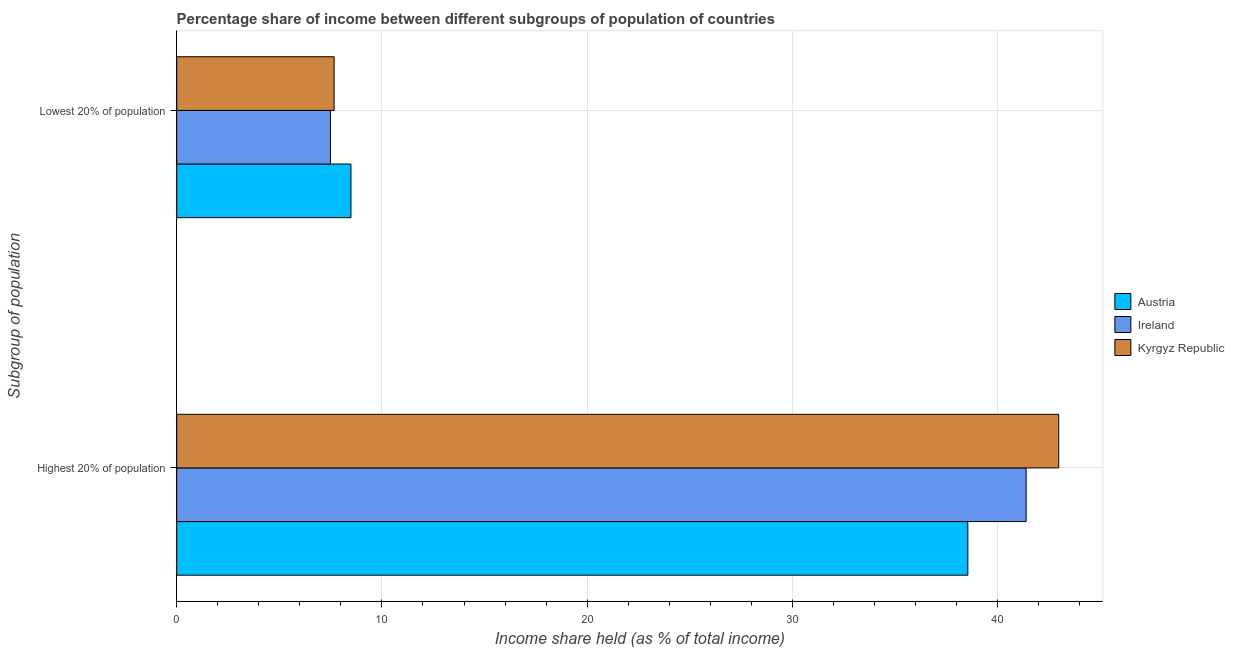How many different coloured bars are there?
Make the answer very short. 3. How many groups of bars are there?
Provide a succinct answer. 2. Are the number of bars per tick equal to the number of legend labels?
Provide a short and direct response. Yes. How many bars are there on the 2nd tick from the bottom?
Your response must be concise. 3. What is the label of the 2nd group of bars from the top?
Your response must be concise. Highest 20% of population. What is the income share held by highest 20% of the population in Ireland?
Your answer should be very brief. 41.39. Across all countries, what is the maximum income share held by highest 20% of the population?
Provide a succinct answer. 42.98. Across all countries, what is the minimum income share held by highest 20% of the population?
Your response must be concise. 38.55. In which country was the income share held by highest 20% of the population maximum?
Your response must be concise. Kyrgyz Republic. What is the total income share held by lowest 20% of the population in the graph?
Keep it short and to the point. 23.65. What is the difference between the income share held by lowest 20% of the population in Austria and that in Ireland?
Offer a terse response. 1. What is the difference between the income share held by lowest 20% of the population in Austria and the income share held by highest 20% of the population in Ireland?
Provide a succinct answer. -32.9. What is the average income share held by lowest 20% of the population per country?
Offer a terse response. 7.88. What is the difference between the income share held by lowest 20% of the population and income share held by highest 20% of the population in Austria?
Provide a succinct answer. -30.06. In how many countries, is the income share held by lowest 20% of the population greater than 36 %?
Offer a terse response. 0. What is the ratio of the income share held by lowest 20% of the population in Austria to that in Ireland?
Keep it short and to the point. 1.13. Is the income share held by lowest 20% of the population in Austria less than that in Ireland?
Ensure brevity in your answer.  No. In how many countries, is the income share held by lowest 20% of the population greater than the average income share held by lowest 20% of the population taken over all countries?
Offer a very short reply. 1. What does the 2nd bar from the top in Highest 20% of population represents?
Give a very brief answer. Ireland. How many bars are there?
Ensure brevity in your answer.  6. How many countries are there in the graph?
Your answer should be compact. 3. Does the graph contain grids?
Keep it short and to the point. Yes. How many legend labels are there?
Your answer should be very brief. 3. What is the title of the graph?
Offer a very short reply. Percentage share of income between different subgroups of population of countries. What is the label or title of the X-axis?
Offer a terse response. Income share held (as % of total income). What is the label or title of the Y-axis?
Give a very brief answer. Subgroup of population. What is the Income share held (as % of total income) of Austria in Highest 20% of population?
Offer a terse response. 38.55. What is the Income share held (as % of total income) in Ireland in Highest 20% of population?
Your answer should be very brief. 41.39. What is the Income share held (as % of total income) of Kyrgyz Republic in Highest 20% of population?
Offer a very short reply. 42.98. What is the Income share held (as % of total income) of Austria in Lowest 20% of population?
Provide a short and direct response. 8.49. What is the Income share held (as % of total income) in Ireland in Lowest 20% of population?
Give a very brief answer. 7.49. What is the Income share held (as % of total income) of Kyrgyz Republic in Lowest 20% of population?
Ensure brevity in your answer.  7.67. Across all Subgroup of population, what is the maximum Income share held (as % of total income) of Austria?
Ensure brevity in your answer.  38.55. Across all Subgroup of population, what is the maximum Income share held (as % of total income) in Ireland?
Offer a terse response. 41.39. Across all Subgroup of population, what is the maximum Income share held (as % of total income) of Kyrgyz Republic?
Offer a terse response. 42.98. Across all Subgroup of population, what is the minimum Income share held (as % of total income) in Austria?
Give a very brief answer. 8.49. Across all Subgroup of population, what is the minimum Income share held (as % of total income) of Ireland?
Your answer should be compact. 7.49. Across all Subgroup of population, what is the minimum Income share held (as % of total income) in Kyrgyz Republic?
Offer a very short reply. 7.67. What is the total Income share held (as % of total income) of Austria in the graph?
Offer a terse response. 47.04. What is the total Income share held (as % of total income) in Ireland in the graph?
Provide a succinct answer. 48.88. What is the total Income share held (as % of total income) in Kyrgyz Republic in the graph?
Keep it short and to the point. 50.65. What is the difference between the Income share held (as % of total income) of Austria in Highest 20% of population and that in Lowest 20% of population?
Offer a terse response. 30.06. What is the difference between the Income share held (as % of total income) in Ireland in Highest 20% of population and that in Lowest 20% of population?
Your response must be concise. 33.9. What is the difference between the Income share held (as % of total income) of Kyrgyz Republic in Highest 20% of population and that in Lowest 20% of population?
Ensure brevity in your answer.  35.31. What is the difference between the Income share held (as % of total income) in Austria in Highest 20% of population and the Income share held (as % of total income) in Ireland in Lowest 20% of population?
Offer a terse response. 31.06. What is the difference between the Income share held (as % of total income) in Austria in Highest 20% of population and the Income share held (as % of total income) in Kyrgyz Republic in Lowest 20% of population?
Ensure brevity in your answer.  30.88. What is the difference between the Income share held (as % of total income) in Ireland in Highest 20% of population and the Income share held (as % of total income) in Kyrgyz Republic in Lowest 20% of population?
Provide a short and direct response. 33.72. What is the average Income share held (as % of total income) of Austria per Subgroup of population?
Provide a short and direct response. 23.52. What is the average Income share held (as % of total income) in Ireland per Subgroup of population?
Make the answer very short. 24.44. What is the average Income share held (as % of total income) of Kyrgyz Republic per Subgroup of population?
Provide a short and direct response. 25.32. What is the difference between the Income share held (as % of total income) in Austria and Income share held (as % of total income) in Ireland in Highest 20% of population?
Keep it short and to the point. -2.84. What is the difference between the Income share held (as % of total income) in Austria and Income share held (as % of total income) in Kyrgyz Republic in Highest 20% of population?
Offer a very short reply. -4.43. What is the difference between the Income share held (as % of total income) in Ireland and Income share held (as % of total income) in Kyrgyz Republic in Highest 20% of population?
Provide a short and direct response. -1.59. What is the difference between the Income share held (as % of total income) in Austria and Income share held (as % of total income) in Kyrgyz Republic in Lowest 20% of population?
Provide a succinct answer. 0.82. What is the difference between the Income share held (as % of total income) in Ireland and Income share held (as % of total income) in Kyrgyz Republic in Lowest 20% of population?
Provide a succinct answer. -0.18. What is the ratio of the Income share held (as % of total income) of Austria in Highest 20% of population to that in Lowest 20% of population?
Offer a very short reply. 4.54. What is the ratio of the Income share held (as % of total income) of Ireland in Highest 20% of population to that in Lowest 20% of population?
Ensure brevity in your answer.  5.53. What is the ratio of the Income share held (as % of total income) in Kyrgyz Republic in Highest 20% of population to that in Lowest 20% of population?
Offer a terse response. 5.6. What is the difference between the highest and the second highest Income share held (as % of total income) in Austria?
Your response must be concise. 30.06. What is the difference between the highest and the second highest Income share held (as % of total income) of Ireland?
Provide a succinct answer. 33.9. What is the difference between the highest and the second highest Income share held (as % of total income) of Kyrgyz Republic?
Your answer should be compact. 35.31. What is the difference between the highest and the lowest Income share held (as % of total income) of Austria?
Provide a succinct answer. 30.06. What is the difference between the highest and the lowest Income share held (as % of total income) in Ireland?
Offer a terse response. 33.9. What is the difference between the highest and the lowest Income share held (as % of total income) in Kyrgyz Republic?
Keep it short and to the point. 35.31. 